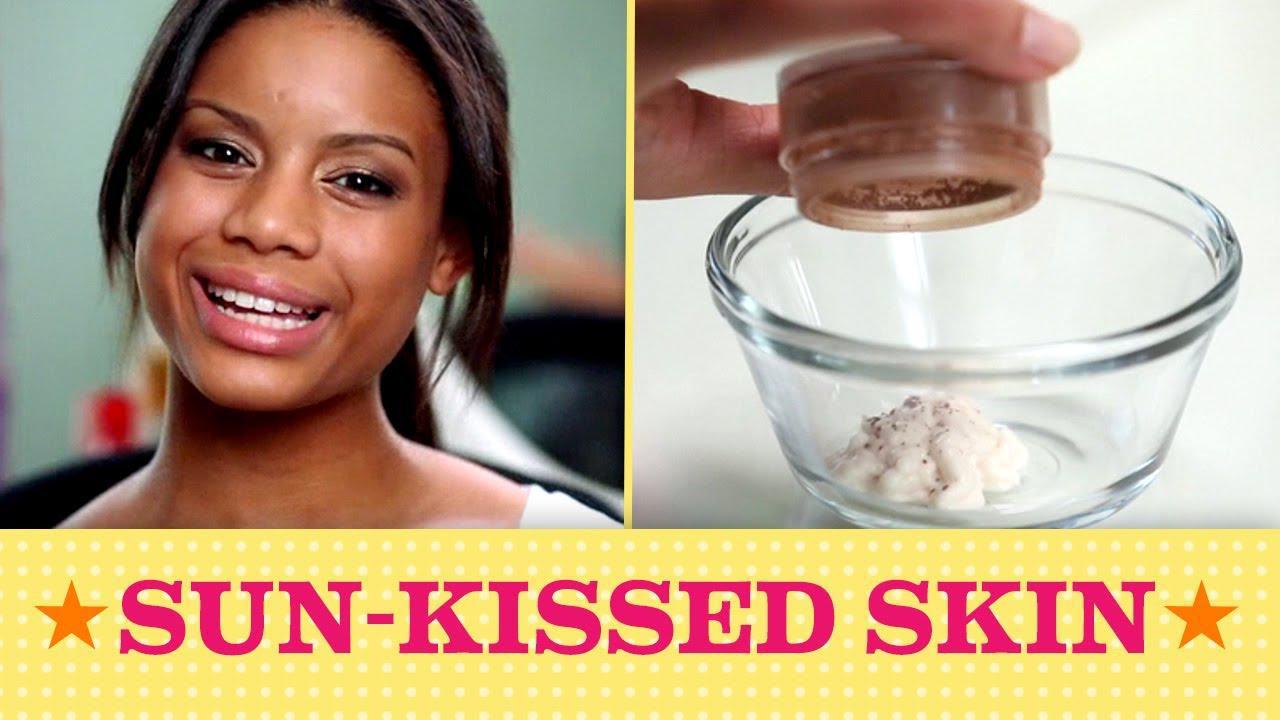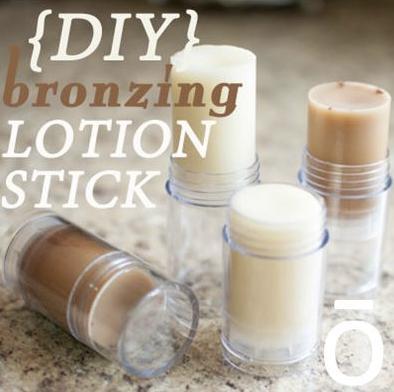The first image is the image on the left, the second image is the image on the right. For the images shown, is this caption "An image includes multiple clear containers filled with white and brown substances." true? Answer yes or no. Yes. The first image is the image on the left, the second image is the image on the right. Given the left and right images, does the statement "Powder sits in a glass bowl in one of the images." hold true? Answer yes or no. Yes. 